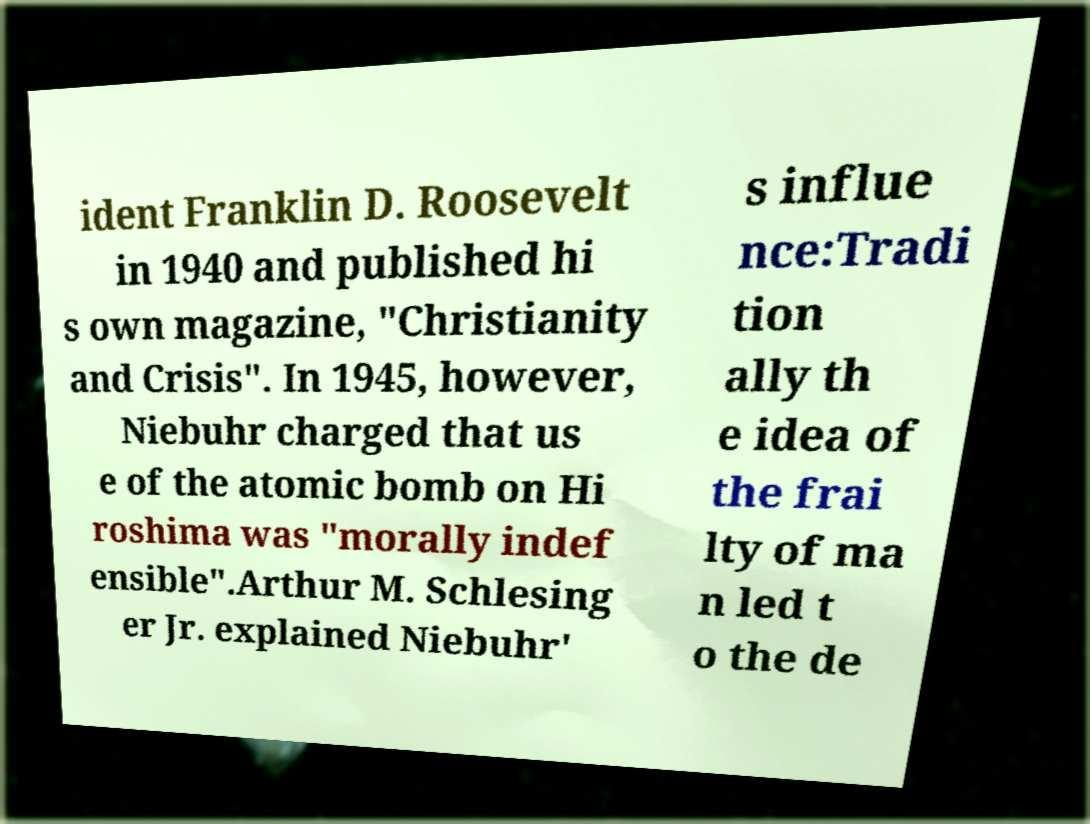For documentation purposes, I need the text within this image transcribed. Could you provide that? ident Franklin D. Roosevelt in 1940 and published hi s own magazine, "Christianity and Crisis". In 1945, however, Niebuhr charged that us e of the atomic bomb on Hi roshima was "morally indef ensible".Arthur M. Schlesing er Jr. explained Niebuhr' s influe nce:Tradi tion ally th e idea of the frai lty of ma n led t o the de 